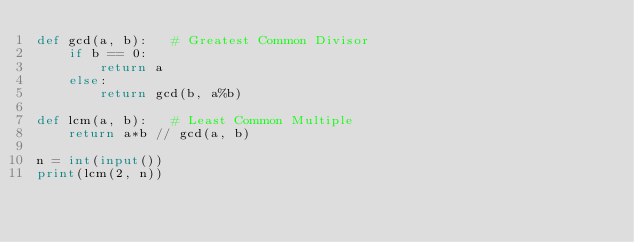<code> <loc_0><loc_0><loc_500><loc_500><_Python_>def gcd(a, b):   # Greatest Common Divisor
    if b == 0:
        return a
    else:
        return gcd(b, a%b)
    
def lcm(a, b):   # Least Common Multiple
    return a*b // gcd(a, b)

n = int(input())
print(lcm(2, n))</code> 